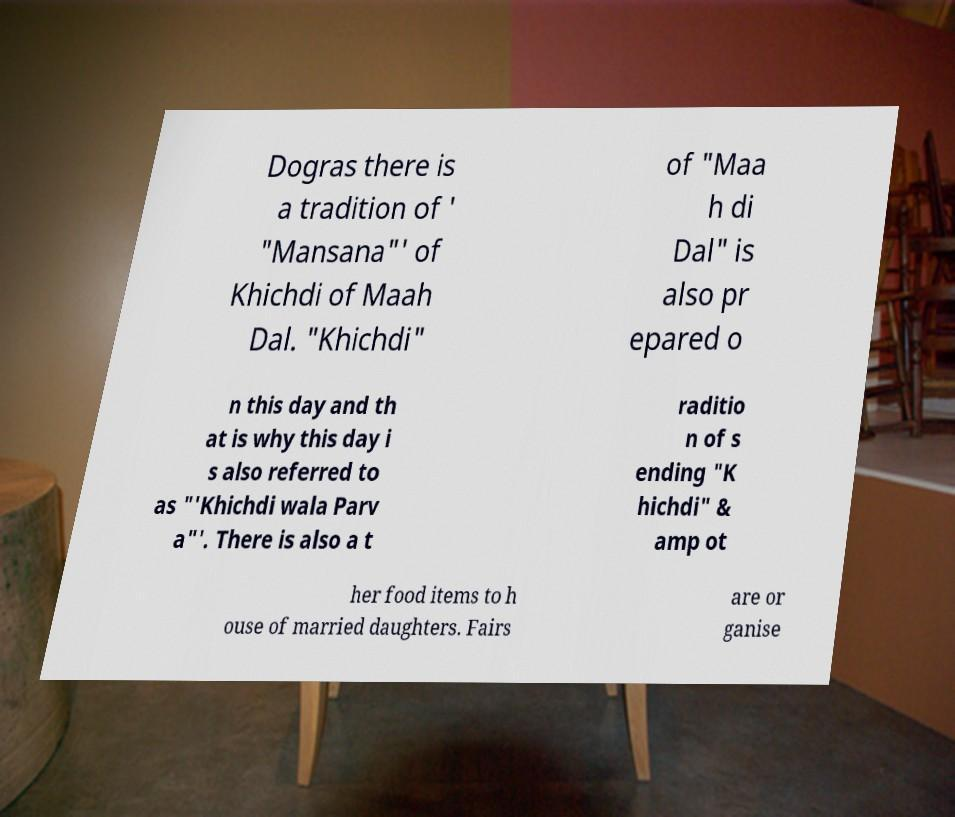What messages or text are displayed in this image? I need them in a readable, typed format. Dogras there is a tradition of ' "Mansana"' of Khichdi of Maah Dal. "Khichdi" of "Maa h di Dal" is also pr epared o n this day and th at is why this day i s also referred to as "'Khichdi wala Parv a"'. There is also a t raditio n of s ending "K hichdi" & amp ot her food items to h ouse of married daughters. Fairs are or ganise 